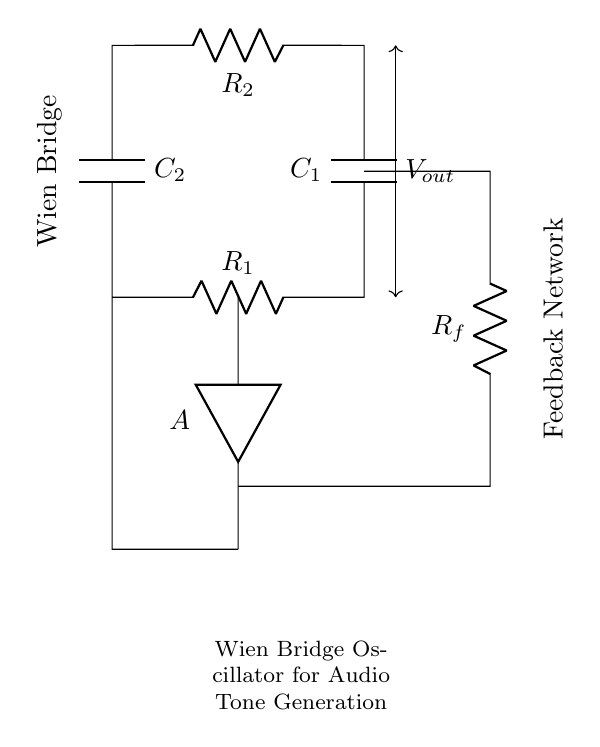What components are present in the Wien bridge oscillator circuit? The circuit includes two resistors, R1 and R2, and two capacitors, C1 and C2. These components are critical for the oscillation process within the circuit.
Answer: Two resistors and two capacitors What is the function of the feedback network in the circuit? The feedback network (R_f) is used to stabilize the oscillation in the Wien bridge oscillator by controlling the gain and ensuring sustained oscillation at a specific frequency.
Answer: Stabilization of oscillation What does the symbol "A" in the circuit represent? The symbol "A" represents the operational amplifier that is central to the operation of the Wien bridge oscillator, permitting signal amplification and oscillation generation.
Answer: Operational amplifier How is the output voltage measured in the circuit? The output voltage (V_out) is measured across R2, which is positioned between the junction of the components and the operational amplifier, indicating the signal produced by the oscillation.
Answer: Across R2 Why is it important for R1 and R2 to be equal in value? R1 and R2 being equal ensures that the phase shift required for oscillation is achieved, which is essential for the Wien bridge oscillator to function correctly at its desired frequency.
Answer: Achieves required phase shift What role do the capacitors C1 and C2 play in frequency determination? C1 and C2 are crucial for establishing the timing characteristics of the oscillator, as their values, in tandem with R1 and R2, determine the frequency of the output audio tone generated by the circuit.
Answer: Determine frequency of oscillation What type of oscillator does this circuit represent? The circuit is a Wien bridge oscillator, which is characterized by the specific configuration of resistors and capacitors that allow for the generation of sinusoidal waveforms, often used in audio applications.
Answer: Wien bridge oscillator 